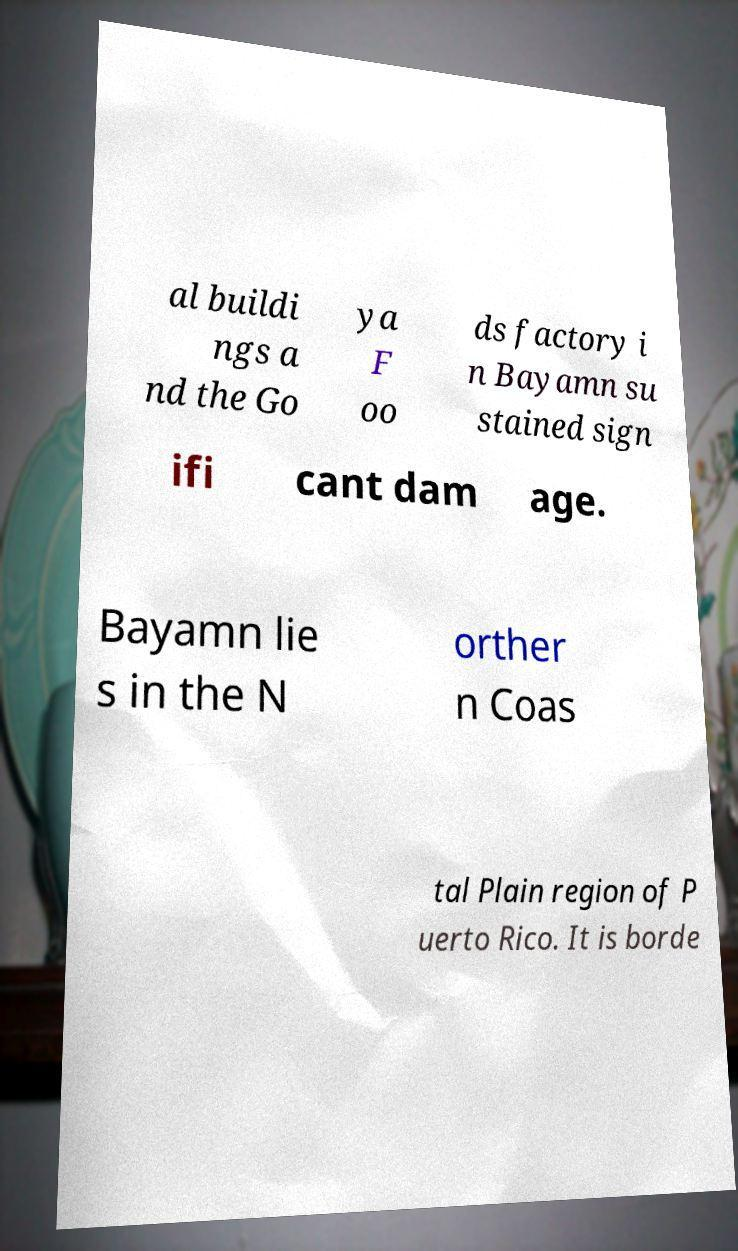Please identify and transcribe the text found in this image. al buildi ngs a nd the Go ya F oo ds factory i n Bayamn su stained sign ifi cant dam age. Bayamn lie s in the N orther n Coas tal Plain region of P uerto Rico. It is borde 